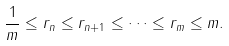<formula> <loc_0><loc_0><loc_500><loc_500>\frac { 1 } { m } \leq r _ { n } \leq r _ { n + 1 } \leq \dots \leq r _ { m } \leq { m } .</formula> 